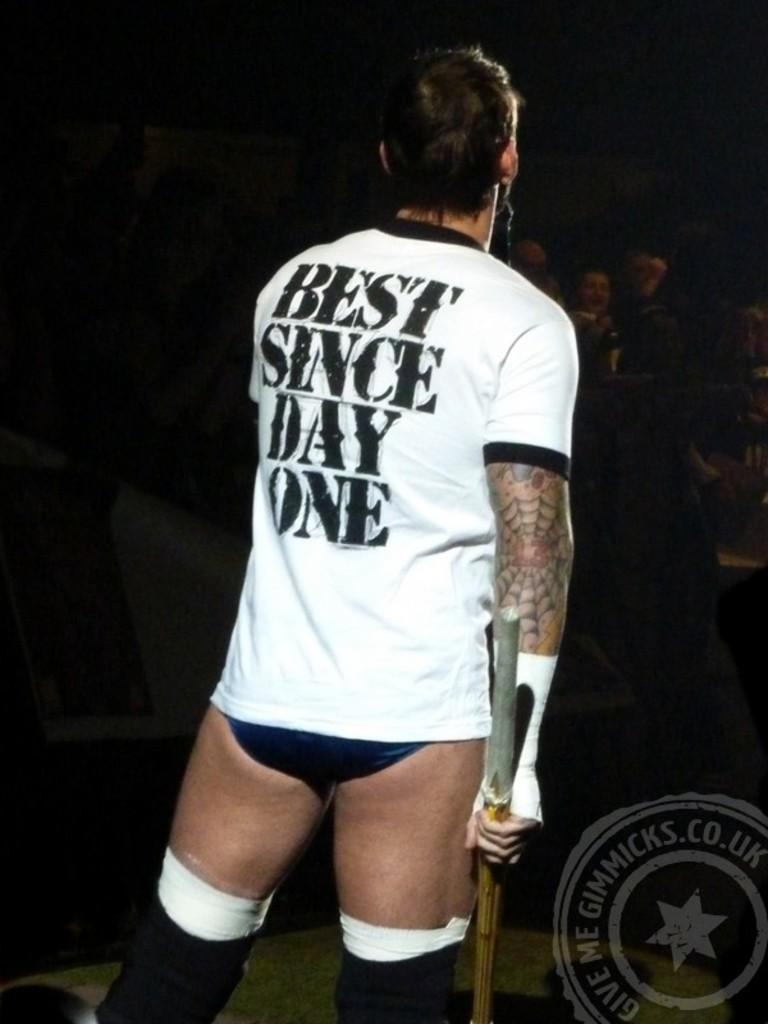<image>
Relay a brief, clear account of the picture shown. A man is wearing a shirt that says, 'Best since day one'. 